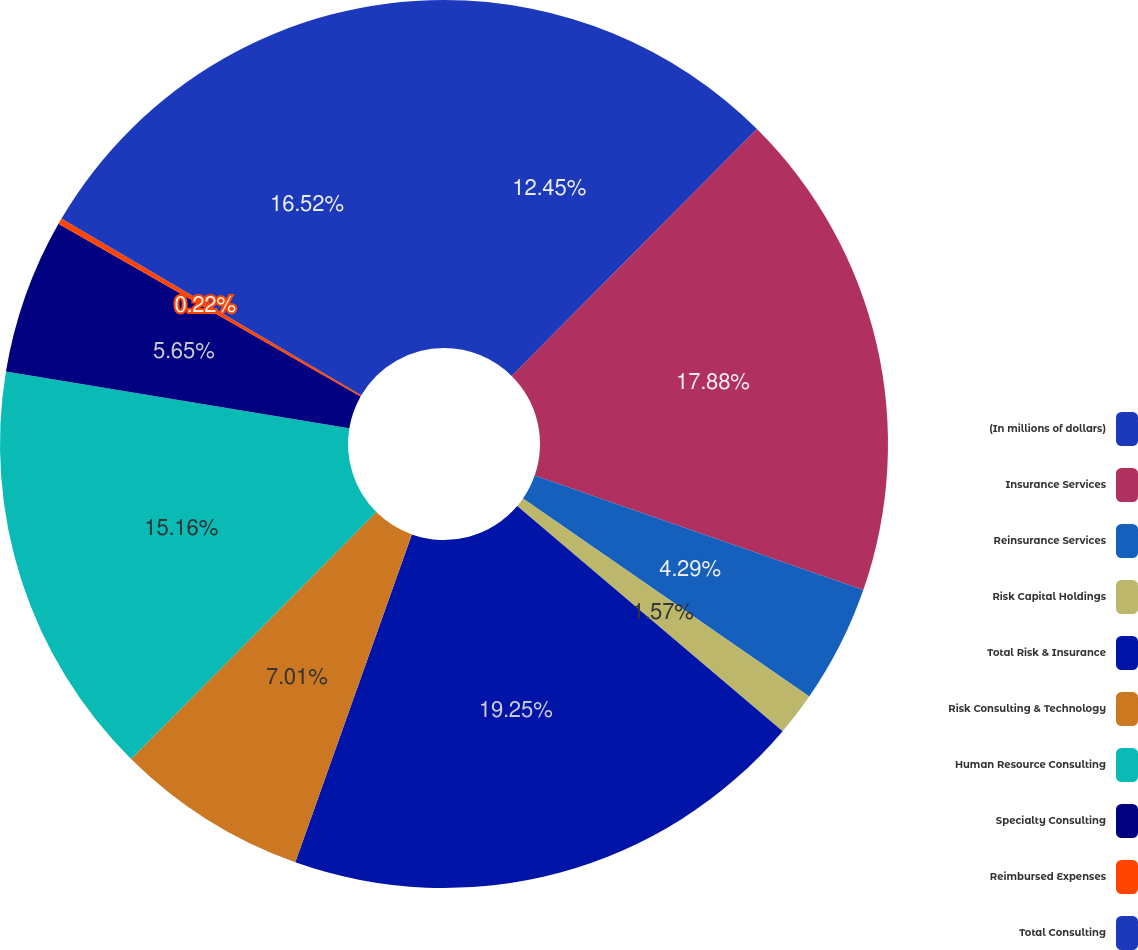Convert chart to OTSL. <chart><loc_0><loc_0><loc_500><loc_500><pie_chart><fcel>(In millions of dollars)<fcel>Insurance Services<fcel>Reinsurance Services<fcel>Risk Capital Holdings<fcel>Total Risk & Insurance<fcel>Risk Consulting & Technology<fcel>Human Resource Consulting<fcel>Specialty Consulting<fcel>Reimbursed Expenses<fcel>Total Consulting<nl><fcel>12.45%<fcel>17.88%<fcel>4.29%<fcel>1.57%<fcel>19.24%<fcel>7.01%<fcel>15.16%<fcel>5.65%<fcel>0.22%<fcel>16.52%<nl></chart> 